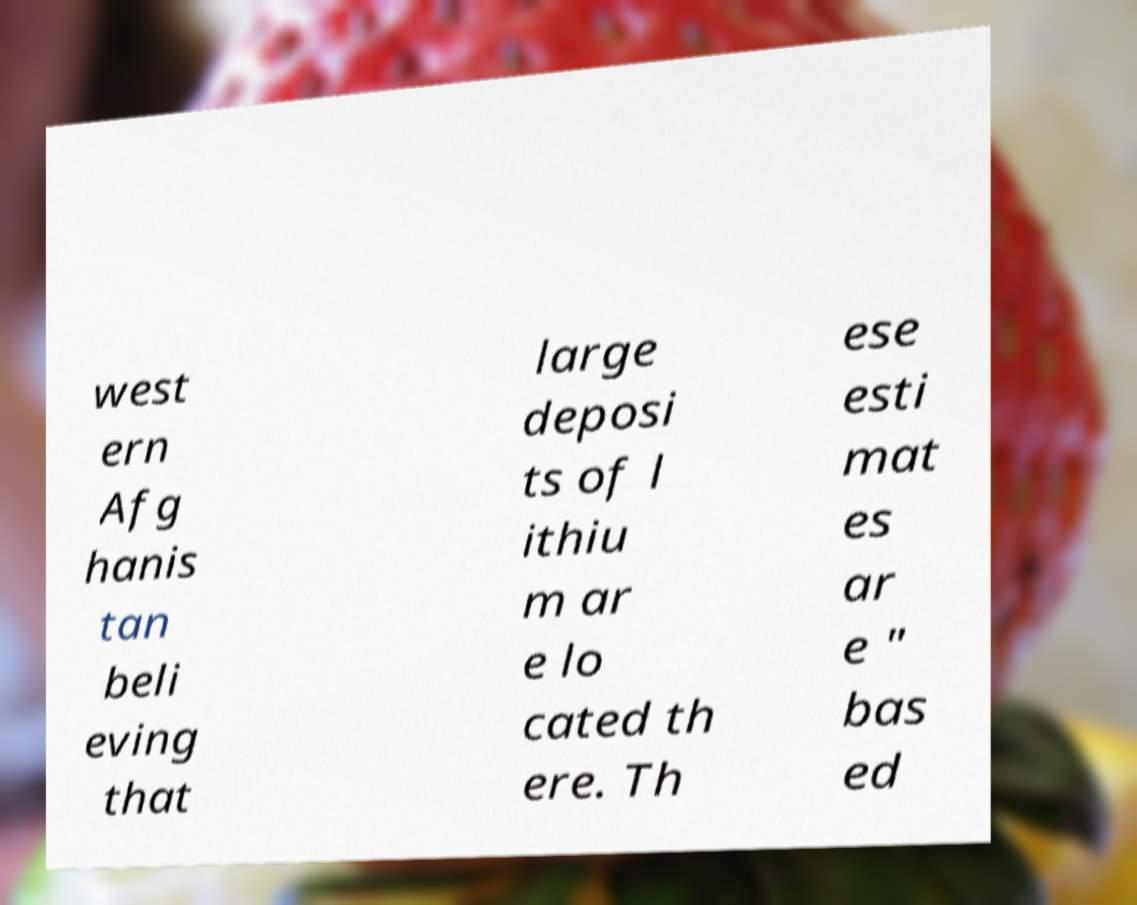Can you accurately transcribe the text from the provided image for me? west ern Afg hanis tan beli eving that large deposi ts of l ithiu m ar e lo cated th ere. Th ese esti mat es ar e " bas ed 